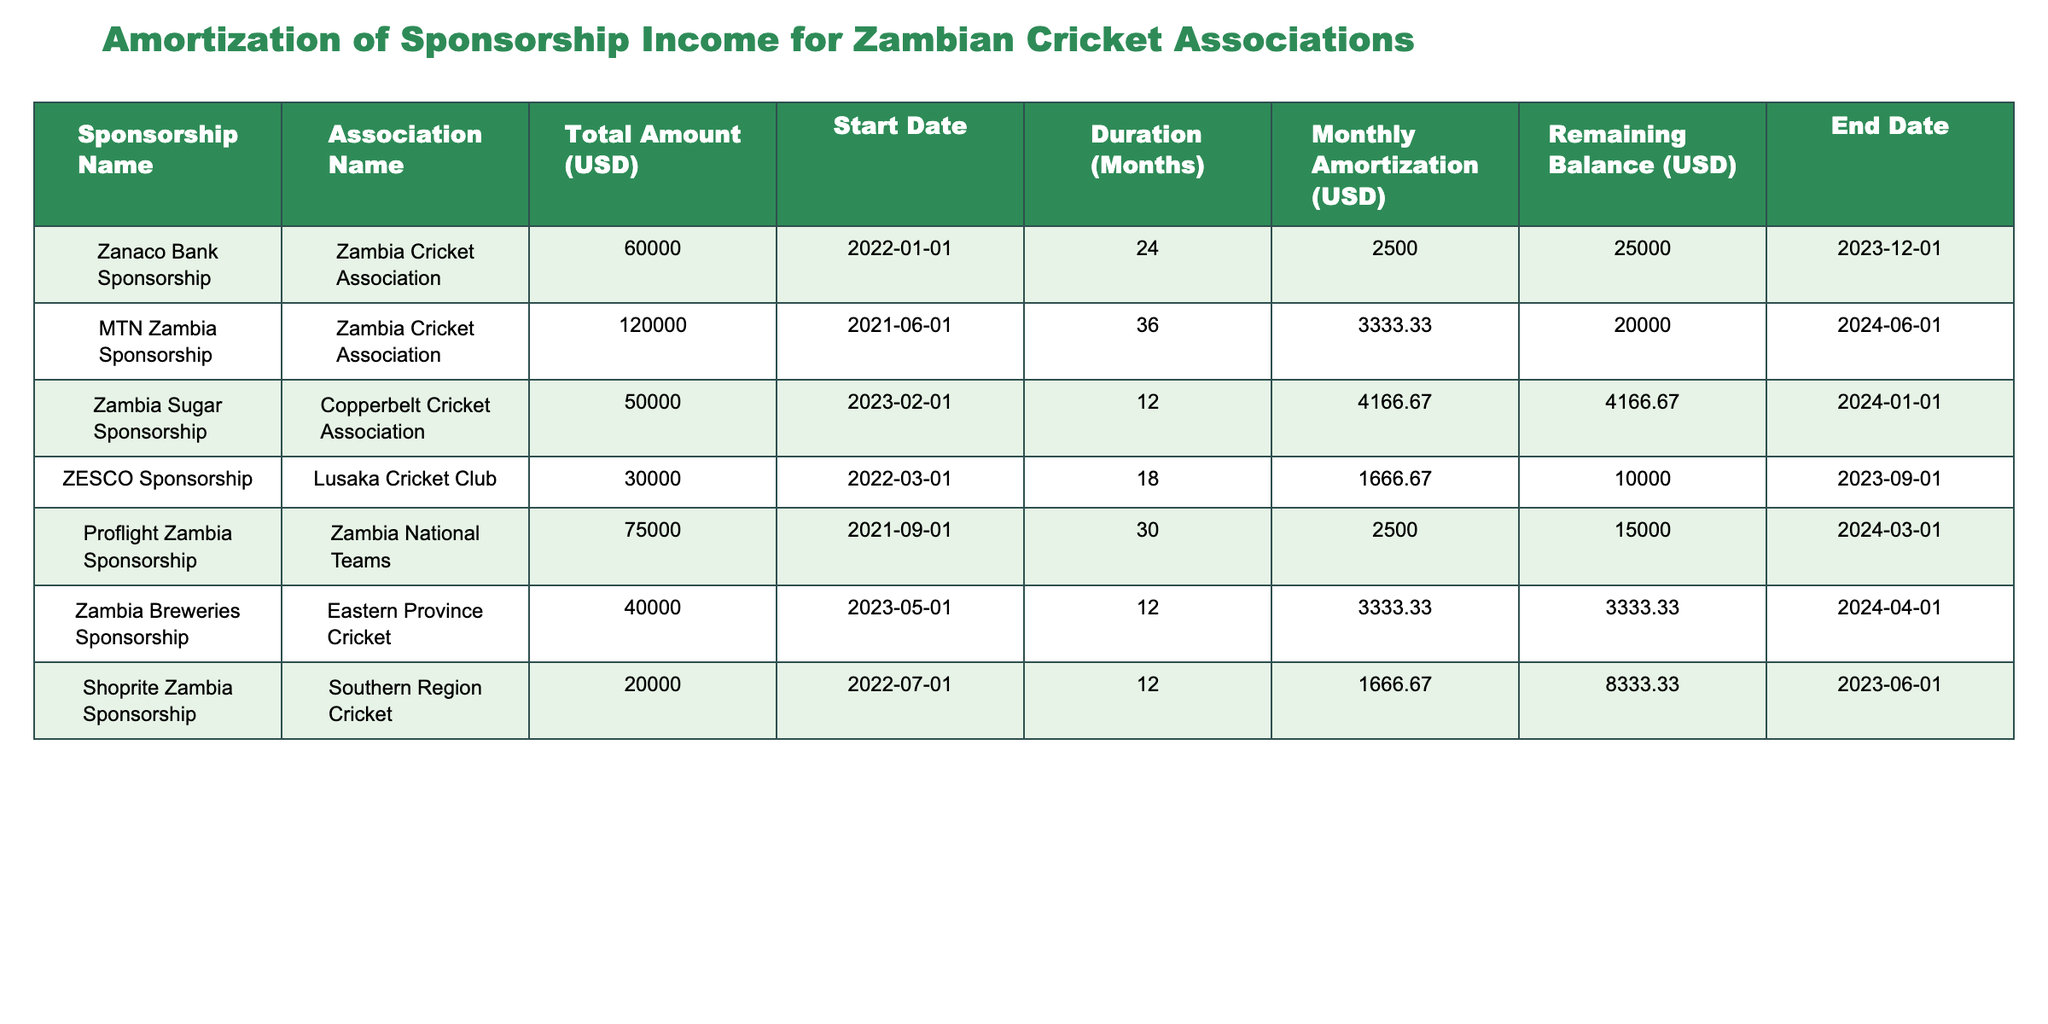What is the total amount of sponsorship income received by the Zambia Cricket Association? From the table, the Zambia Cricket Association has two sponsorships: Zanaco Bank Sponsorship with a total amount of 60000 USD and MTN Zambia Sponsorship with a total amount of 120000 USD. Adding these amounts gives 60000 + 120000 = 180000 USD.
Answer: 180000 USD What is the remaining balance for the Southern Region Cricket sponsorship? The Southern Region Cricket sponsorship, which is the Shoprite Zambia Sponsorship, has a remaining balance as indicated in the table, and it is 8333.33 USD.
Answer: 8333.33 USD Is the monthly amortization for the Zambia Breweries Sponsorship greater than the Shoprite Zambia Sponsorship? The monthly amortization for the Zambia Breweries Sponsorship is 3333.33 USD, and for the Shoprite Zambia Sponsorship, it is 1666.67 USD. Since 3333.33 is greater than 1666.67, the answer is yes.
Answer: Yes What is the total duration of all sponsorships listed in months? To find the total duration, we sum up the durations for each sponsorship: 24 + 36 + 12 + 18 + 30 + 12 + 12 = 144 months. Thus, the total duration of all sponsorships is 144 months.
Answer: 144 months Which sponsorship has the longest duration and what is that duration? Looking through the table, the MTN Zambia Sponsorship has a duration of 36 months, which is the longest compared to the other sponsorships listed.
Answer: MTN Zambia Sponsorship, 36 months What is the average monthly amortization for all sponsorships? To calculate the average monthly amortization, we sum all monthly amortizations: 2500 + 3333.33 + 4166.67 + 1666.67 + 2500 + 3333.33 + 1666.67 = 18666.67 USD. Now, dividing this by the number of sponsorships, which is 7, yields an average of 18666.67 / 7 = 2666.67 USD.
Answer: 2666.67 USD Is there any sponsorship with an end date in 2024? By examining the end dates in the table, the MTN Zambia Sponsorship ends on 2024-06-01, the Zambia Sugar Sponsorship ends on 2024-01-01, the Proflight Zambia Sponsorship ends on 2024-03-01, and the Zambia Breweries Sponsorship ends on 2024-04-01. This confirms that there are sponsorships with an end date in 2024.
Answer: Yes Which association has the highest remaining balance and what is that amount? From the table, we assess all remaining balances: 25000, 20000, 4166.67, 10000, 15000, 3333.33, and 8333.33. The highest among these is 25000 USD, corresponding to the Zanaco Bank Sponsorship for the Zambia Cricket Association.
Answer: Zambia Cricket Association, 25000 USD What is the remaining balance for Copperbelt Cricket Association after one month of amortization? The Copperbelt Cricket Association's Zambia Sugar Sponsorship has a remaining balance of 4166.67 USD. After one month of amortization of 4166.67 USD, the remaining balance would be zero. Since the current remaining balance is 4166.67, subtracting this amount yields 0 USD.
Answer: 0 USD 